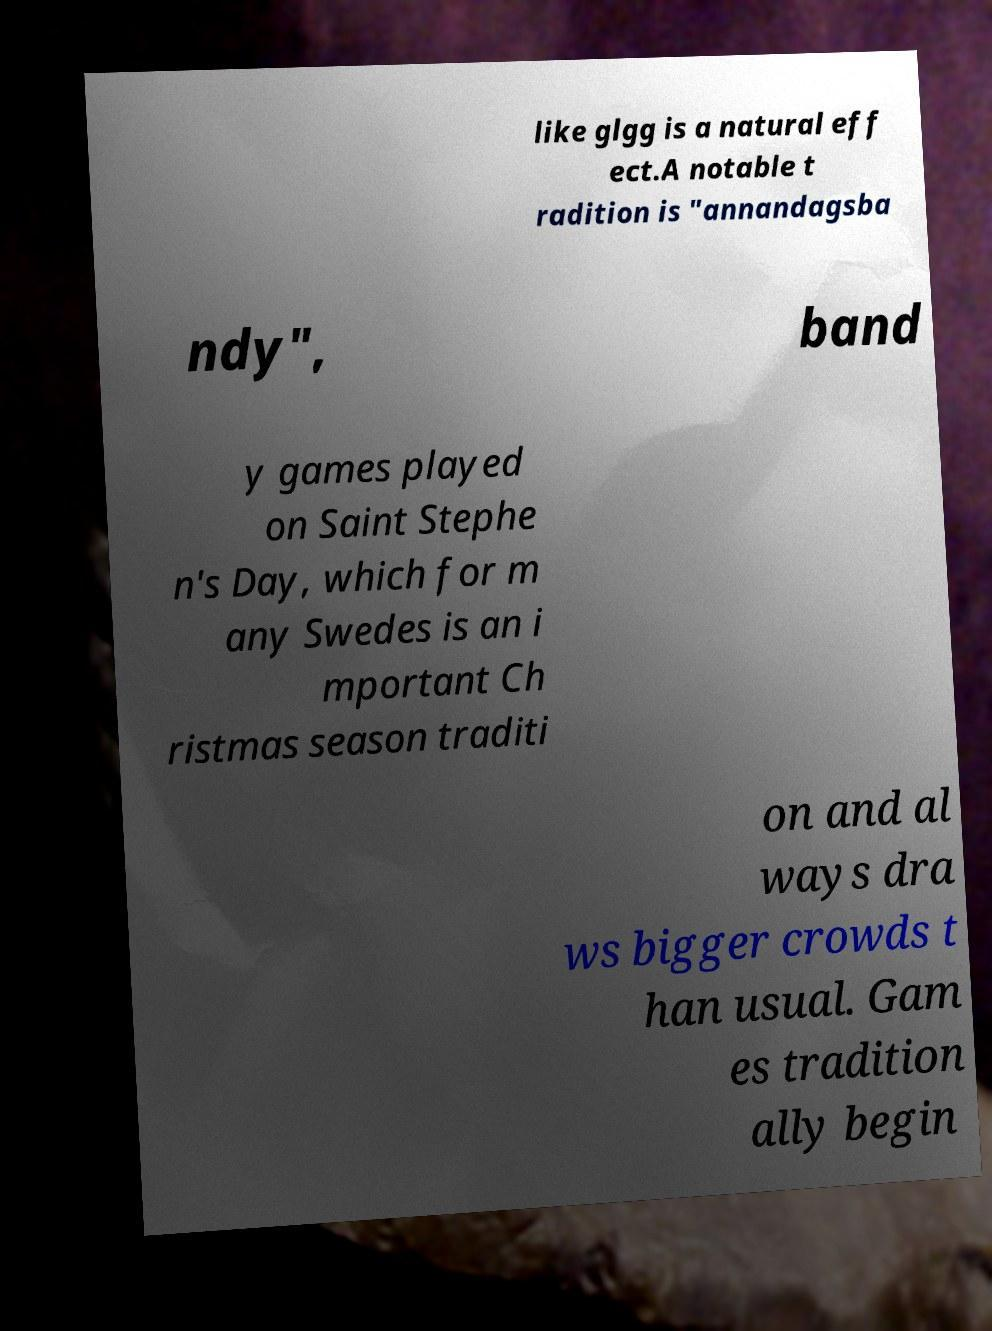Can you read and provide the text displayed in the image?This photo seems to have some interesting text. Can you extract and type it out for me? like glgg is a natural eff ect.A notable t radition is "annandagsba ndy", band y games played on Saint Stephe n's Day, which for m any Swedes is an i mportant Ch ristmas season traditi on and al ways dra ws bigger crowds t han usual. Gam es tradition ally begin 